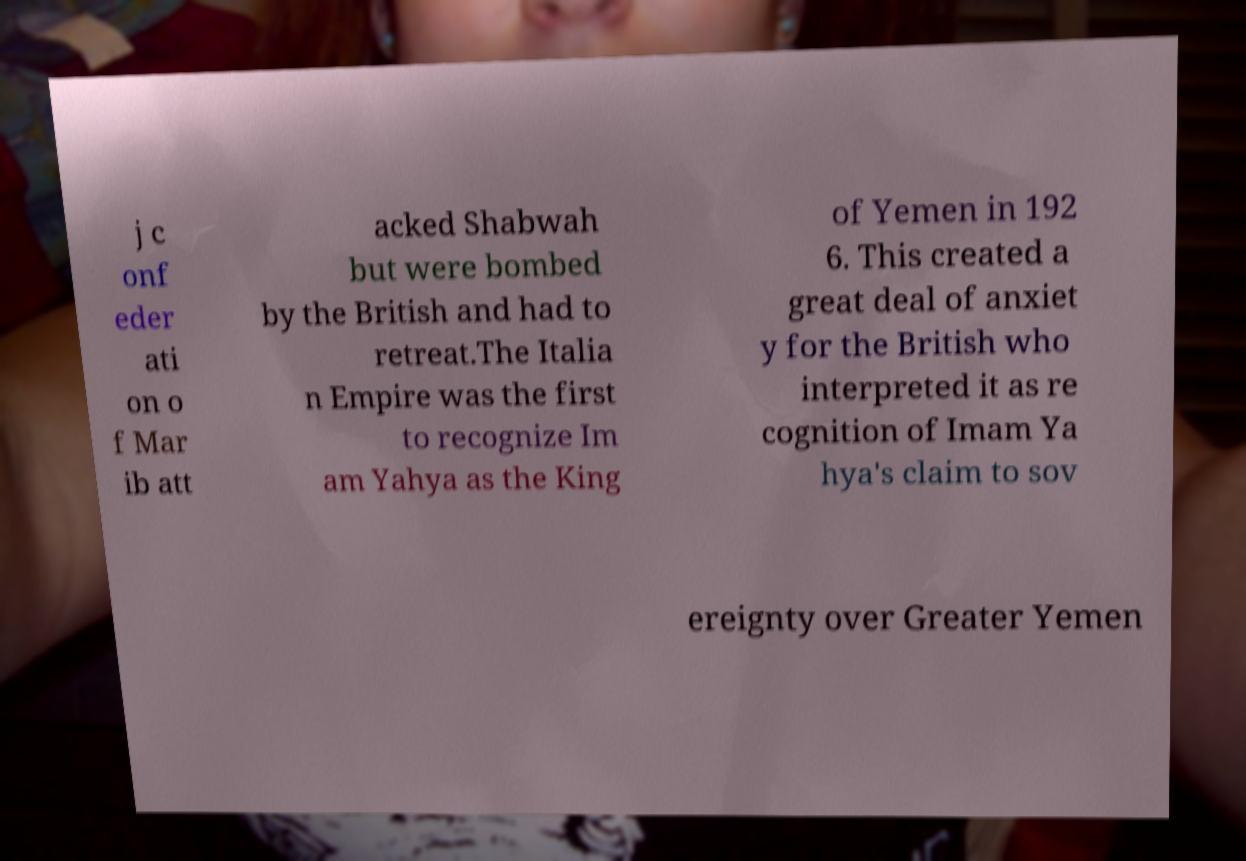Could you assist in decoding the text presented in this image and type it out clearly? j c onf eder ati on o f Mar ib att acked Shabwah but were bombed by the British and had to retreat.The Italia n Empire was the first to recognize Im am Yahya as the King of Yemen in 192 6. This created a great deal of anxiet y for the British who interpreted it as re cognition of Imam Ya hya's claim to sov ereignty over Greater Yemen 